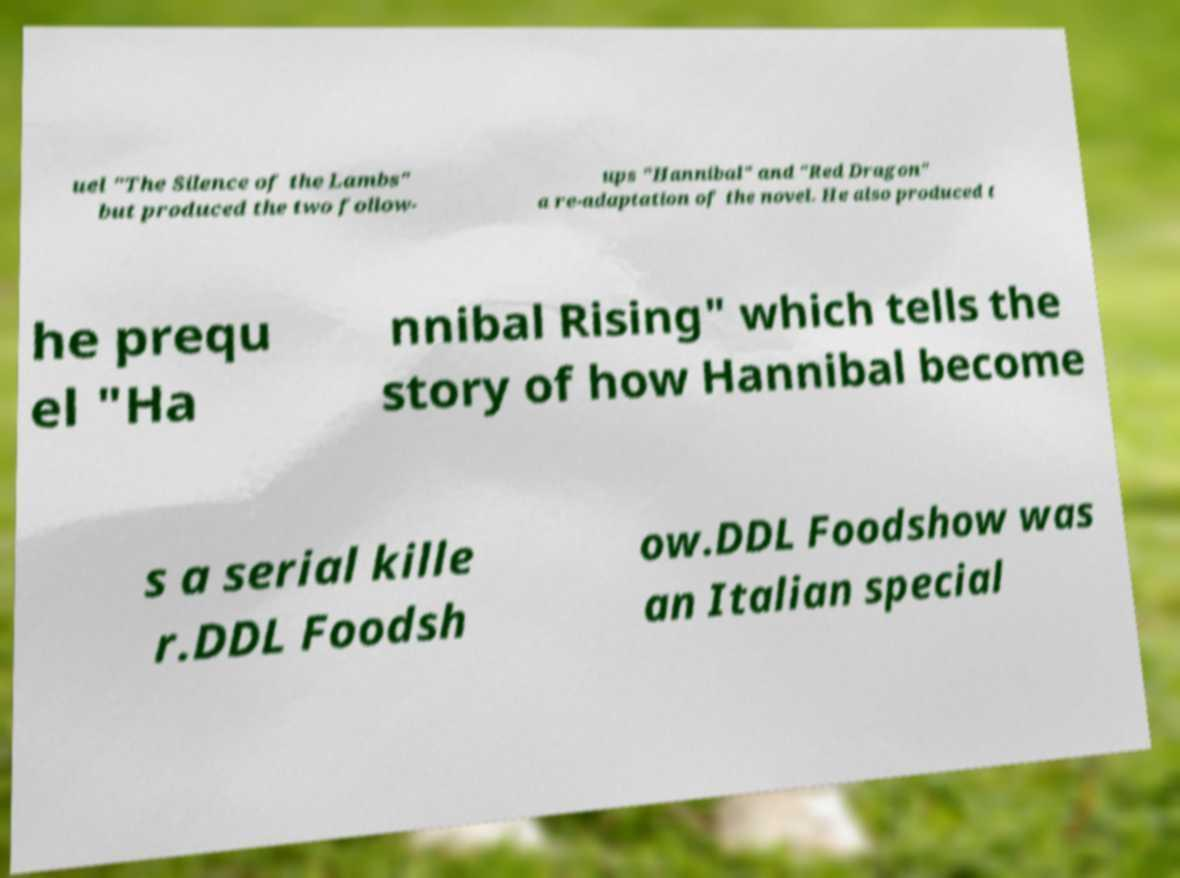Can you accurately transcribe the text from the provided image for me? uel "The Silence of the Lambs" but produced the two follow- ups "Hannibal" and "Red Dragon" a re-adaptation of the novel. He also produced t he prequ el "Ha nnibal Rising" which tells the story of how Hannibal become s a serial kille r.DDL Foodsh ow.DDL Foodshow was an Italian special 